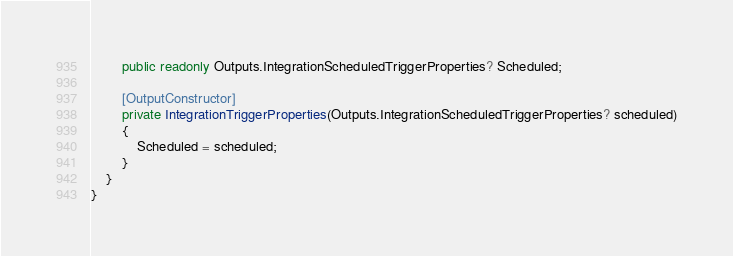Convert code to text. <code><loc_0><loc_0><loc_500><loc_500><_C#_>        public readonly Outputs.IntegrationScheduledTriggerProperties? Scheduled;

        [OutputConstructor]
        private IntegrationTriggerProperties(Outputs.IntegrationScheduledTriggerProperties? scheduled)
        {
            Scheduled = scheduled;
        }
    }
}
</code> 